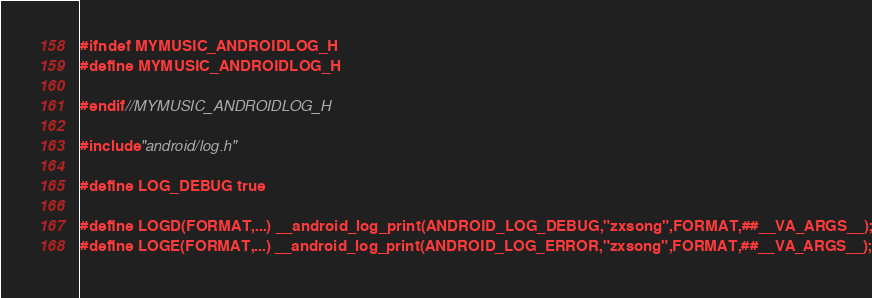Convert code to text. <code><loc_0><loc_0><loc_500><loc_500><_C_>
#ifndef MYMUSIC_ANDROIDLOG_H
#define MYMUSIC_ANDROIDLOG_H

#endif //MYMUSIC_ANDROIDLOG_H

#include "android/log.h"

#define LOG_DEBUG true

#define LOGD(FORMAT,...) __android_log_print(ANDROID_LOG_DEBUG,"zxsong",FORMAT,##__VA_ARGS__);
#define LOGE(FORMAT,...) __android_log_print(ANDROID_LOG_ERROR,"zxsong",FORMAT,##__VA_ARGS__);
</code> 